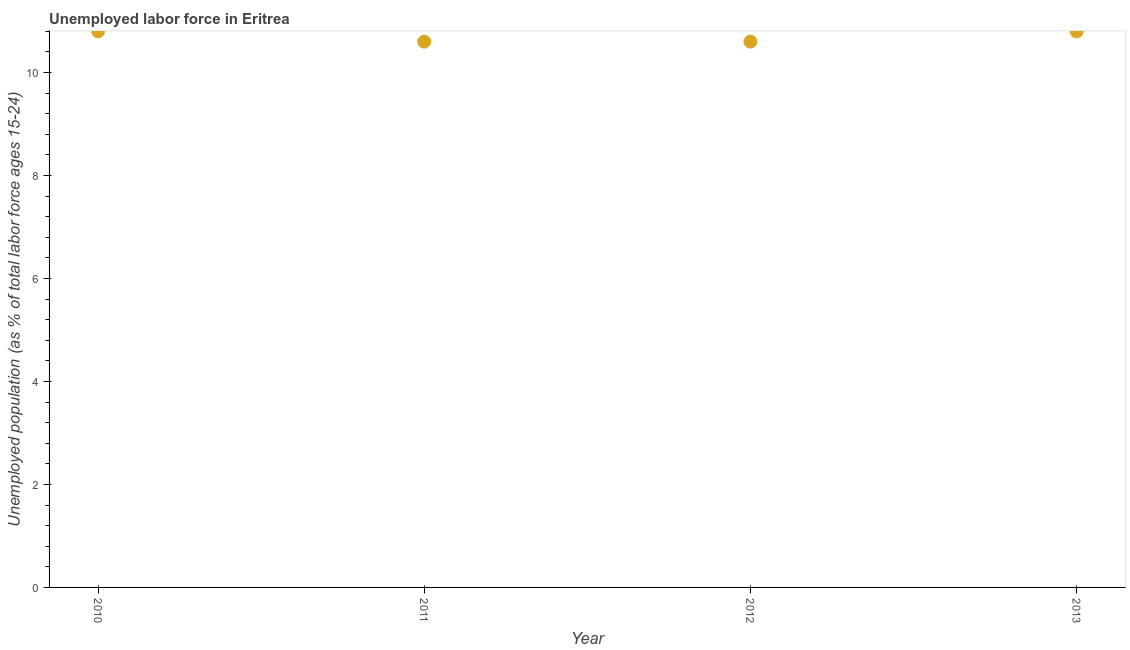What is the total unemployed youth population in 2010?
Provide a succinct answer. 10.8. Across all years, what is the maximum total unemployed youth population?
Keep it short and to the point. 10.8. Across all years, what is the minimum total unemployed youth population?
Make the answer very short. 10.6. In which year was the total unemployed youth population maximum?
Provide a short and direct response. 2010. What is the sum of the total unemployed youth population?
Your answer should be compact. 42.8. What is the difference between the total unemployed youth population in 2012 and 2013?
Give a very brief answer. -0.2. What is the average total unemployed youth population per year?
Provide a short and direct response. 10.7. What is the median total unemployed youth population?
Offer a very short reply. 10.7. In how many years, is the total unemployed youth population greater than 8 %?
Keep it short and to the point. 4. Do a majority of the years between 2011 and 2010 (inclusive) have total unemployed youth population greater than 3.2 %?
Your response must be concise. No. What is the ratio of the total unemployed youth population in 2010 to that in 2011?
Your answer should be compact. 1.02. Is the total unemployed youth population in 2010 less than that in 2012?
Provide a succinct answer. No. Is the difference between the total unemployed youth population in 2011 and 2012 greater than the difference between any two years?
Give a very brief answer. No. What is the difference between the highest and the second highest total unemployed youth population?
Your answer should be very brief. 0. Is the sum of the total unemployed youth population in 2011 and 2012 greater than the maximum total unemployed youth population across all years?
Give a very brief answer. Yes. What is the difference between the highest and the lowest total unemployed youth population?
Your answer should be compact. 0.2. In how many years, is the total unemployed youth population greater than the average total unemployed youth population taken over all years?
Offer a terse response. 2. How many dotlines are there?
Your answer should be compact. 1. How many years are there in the graph?
Your answer should be compact. 4. Are the values on the major ticks of Y-axis written in scientific E-notation?
Offer a very short reply. No. Does the graph contain any zero values?
Provide a succinct answer. No. What is the title of the graph?
Make the answer very short. Unemployed labor force in Eritrea. What is the label or title of the Y-axis?
Keep it short and to the point. Unemployed population (as % of total labor force ages 15-24). What is the Unemployed population (as % of total labor force ages 15-24) in 2010?
Keep it short and to the point. 10.8. What is the Unemployed population (as % of total labor force ages 15-24) in 2011?
Make the answer very short. 10.6. What is the Unemployed population (as % of total labor force ages 15-24) in 2012?
Provide a short and direct response. 10.6. What is the Unemployed population (as % of total labor force ages 15-24) in 2013?
Your answer should be compact. 10.8. What is the difference between the Unemployed population (as % of total labor force ages 15-24) in 2010 and 2012?
Your answer should be compact. 0.2. What is the ratio of the Unemployed population (as % of total labor force ages 15-24) in 2011 to that in 2012?
Provide a succinct answer. 1. What is the ratio of the Unemployed population (as % of total labor force ages 15-24) in 2012 to that in 2013?
Offer a very short reply. 0.98. 